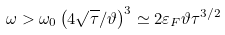Convert formula to latex. <formula><loc_0><loc_0><loc_500><loc_500>\omega > \omega _ { 0 } \left ( { 4 \sqrt { \tau } } / { \vartheta } \right ) ^ { 3 } \simeq { 2 } \varepsilon _ { F } \vartheta \tau ^ { 3 / 2 }</formula> 